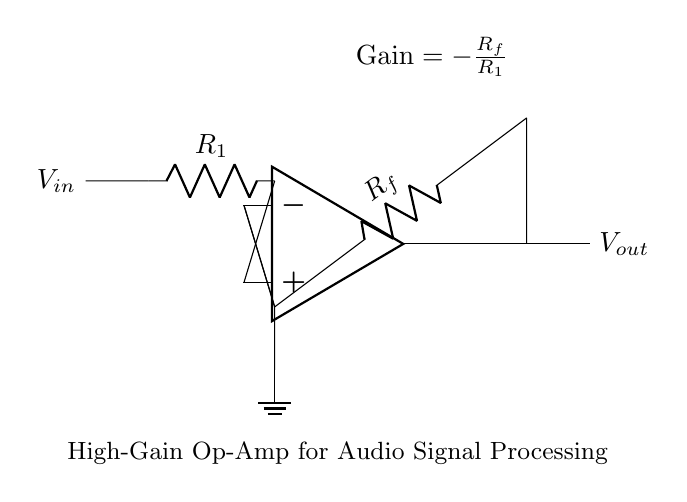What is the input voltage labeled in the circuit? The input voltage is labeled as V_in in the circuit diagram, which indicates where the initial audio signal enters the operational amplifier.
Answer: V_in What does R_f represent in the circuit? R_f denotes the feedback resistor in the circuit, which plays a crucial role in determining the gain of the operational amplifier by providing feedback to the inverting input.
Answer: Feedback resistor What is the expression for gain shown in the diagram? The gain expression, placed above the output node, indicates that the gain is calculated as negative feedback resistance divided by the input resistance (R_f / R_1), which is essential for understanding the amplification factor used in audio processing.
Answer: -R_f/R_1 How is the output voltage derived in this amplifier circuit? The output voltage, V_out, is derived by applying the gain to the input voltage (V_in), expressed in the formula as V_out = Gain * V_in, which incorporates the negative sign indicating phase inversion.
Answer: V_out = -R_f/R_1 * V_in What type of amplifier configuration is shown here? The circuit implements an inverting amplifier configuration, as signified by how the input and feedback resistors are arranged with one input connected to the inverting terminal, resulting in phase-inversion of the output signal.
Answer: Inverting amplifier What is the role of the ground in this circuit? The ground in the circuit provides a reference point for the input and output signals, ensuring that the voltages are measured relative to a common point, facilitating proper functioning of the operational amplifier.
Answer: Reference point How many resistors are present in the circuit? There are two resistors shown in the circuit: R_1 and R_f, each serving different purposes in establishing the gain characteristics for the audio signal processing application.
Answer: Two resistors 